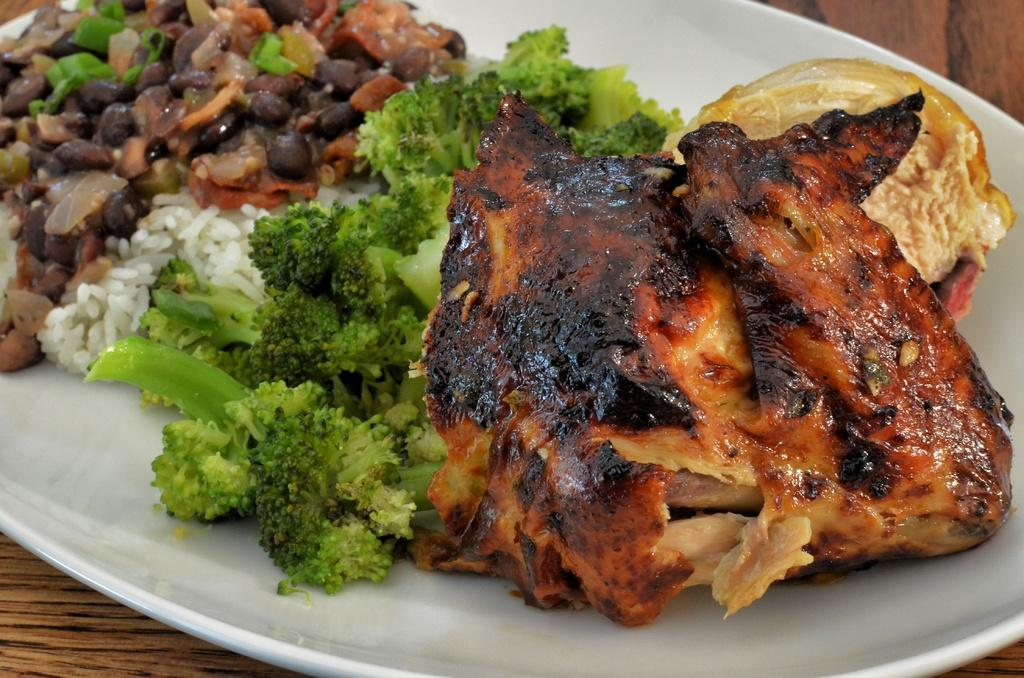What types of food can be seen in the image? There is meat, broccoli, and rice in the image. Can you describe the unspecified food item on the platter? Unfortunately, the specific food item on the white platter is not mentioned in the facts provided. What is the platter placed on in the image? The platter is on a wooden surface in the image. What type of winter clothing is visible in the image? There is no mention of winter clothing in the image; it features food items and a platter on a wooden surface. How many babies are present in the image? There are no babies present in the image; it features food items and a platter on a wooden surface. 